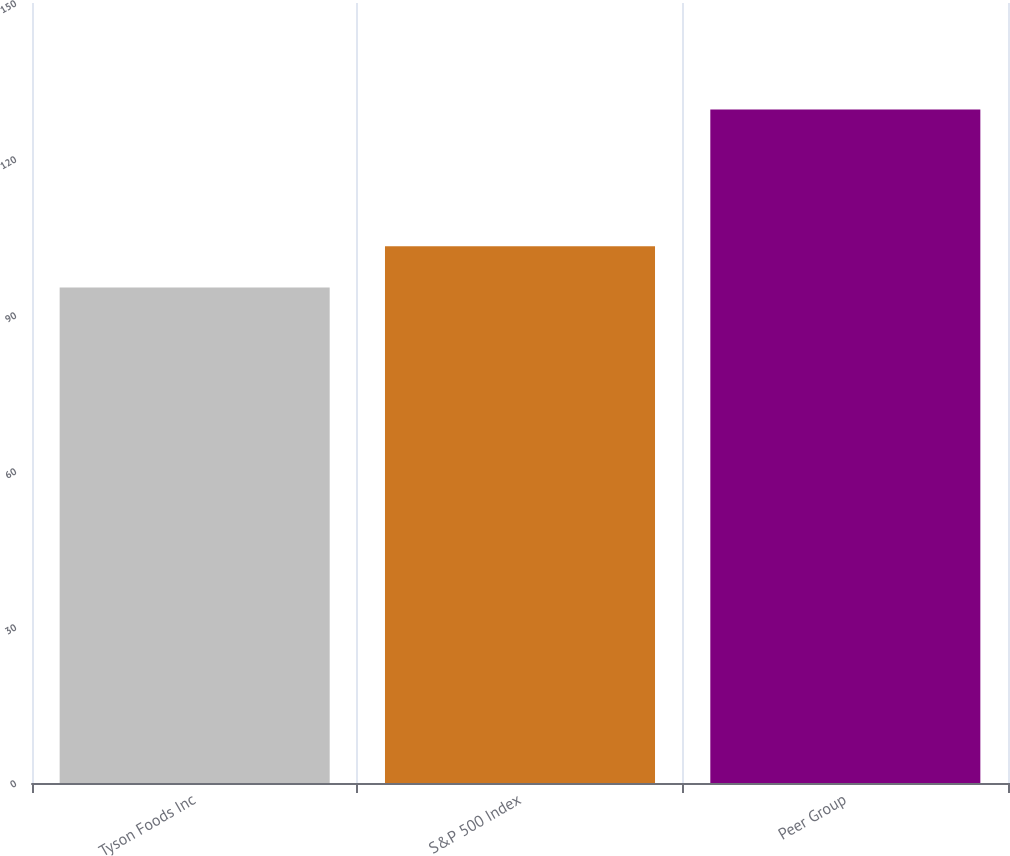Convert chart. <chart><loc_0><loc_0><loc_500><loc_500><bar_chart><fcel>Tyson Foods Inc<fcel>S&P 500 Index<fcel>Peer Group<nl><fcel>95.31<fcel>103.22<fcel>129.53<nl></chart> 